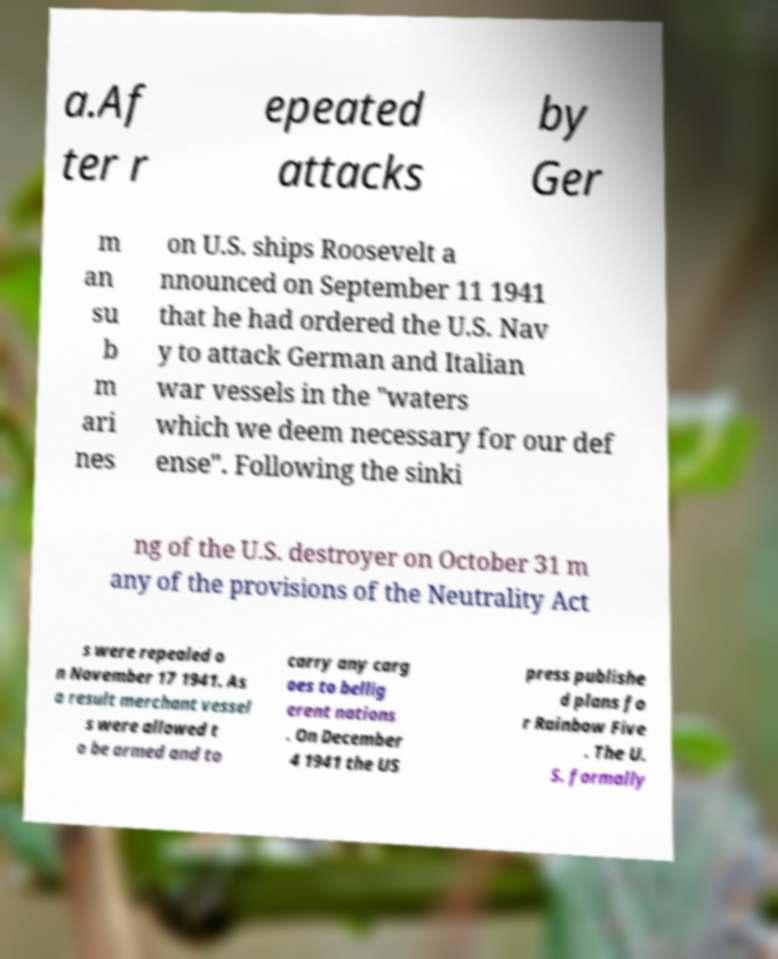Could you extract and type out the text from this image? a.Af ter r epeated attacks by Ger m an su b m ari nes on U.S. ships Roosevelt a nnounced on September 11 1941 that he had ordered the U.S. Nav y to attack German and Italian war vessels in the "waters which we deem necessary for our def ense". Following the sinki ng of the U.S. destroyer on October 31 m any of the provisions of the Neutrality Act s were repealed o n November 17 1941. As a result merchant vessel s were allowed t o be armed and to carry any carg oes to bellig erent nations . On December 4 1941 the US press publishe d plans fo r Rainbow Five . The U. S. formally 